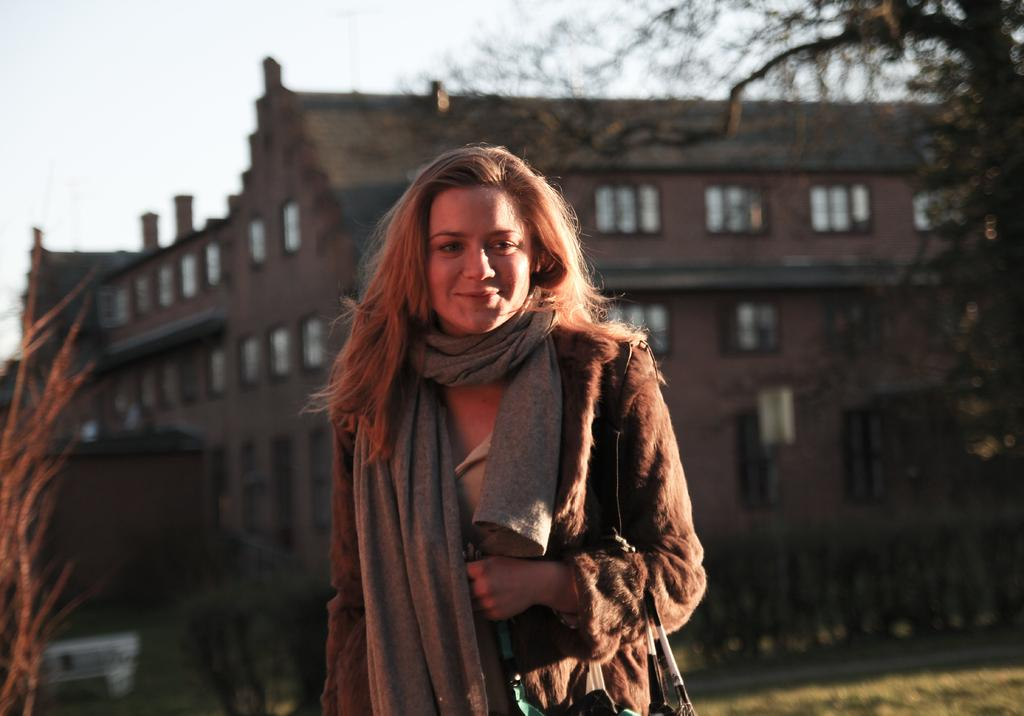Who is present in the image? There is a person in the image. What is the person's facial expression? The person is smiling. What type of vegetation can be seen on the right side of the image? There are trees on the right side of the image. What is visible in the background of the image? There is a building in the background of the image. How many ducks are visible in the image? There are no ducks present in the image. What type of boundary is visible in the image? There is no specific boundary mentioned in the image; it only features a person, trees, and a building. 